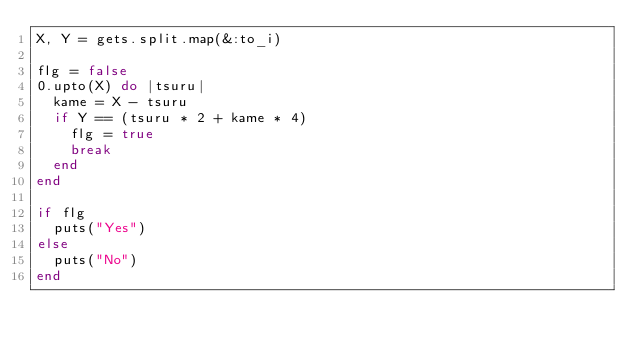Convert code to text. <code><loc_0><loc_0><loc_500><loc_500><_Ruby_>X, Y = gets.split.map(&:to_i)

flg = false
0.upto(X) do |tsuru|
  kame = X - tsuru
  if Y == (tsuru * 2 + kame * 4)
    flg = true
    break
  end
end

if flg
  puts("Yes")
else
  puts("No")
end
</code> 